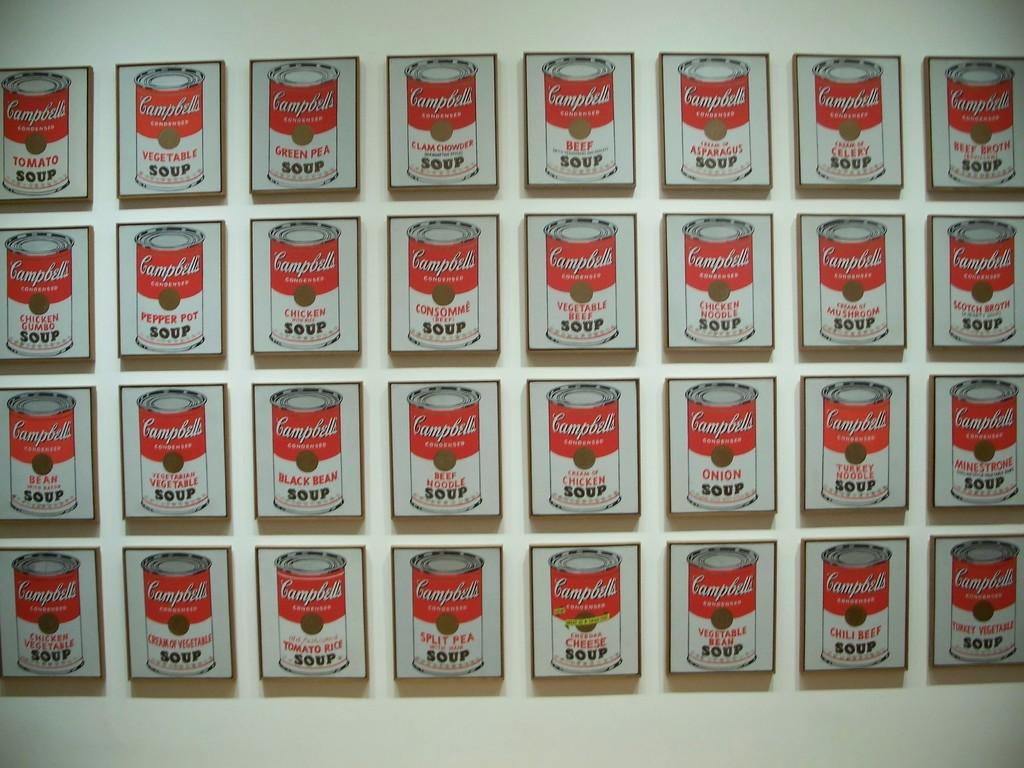What brand of soup is shown?
Provide a succinct answer. Campbells. What kinds of soup are there?
Offer a terse response. Campbells. 